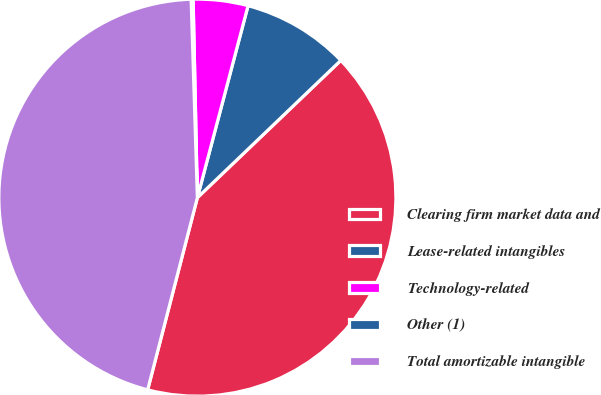<chart> <loc_0><loc_0><loc_500><loc_500><pie_chart><fcel>Clearing firm market data and<fcel>Lease-related intangibles<fcel>Technology-related<fcel>Other (1)<fcel>Total amortizable intangible<nl><fcel>41.18%<fcel>8.74%<fcel>4.45%<fcel>0.16%<fcel>45.47%<nl></chart> 